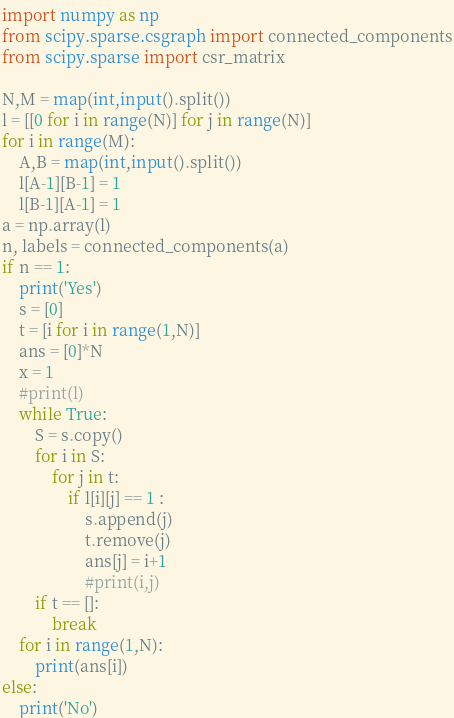<code> <loc_0><loc_0><loc_500><loc_500><_Python_>import numpy as np
from scipy.sparse.csgraph import connected_components
from scipy.sparse import csr_matrix

N,M = map(int,input().split())
l = [[0 for i in range(N)] for j in range(N)]
for i in range(M):
    A,B = map(int,input().split())
    l[A-1][B-1] = 1
    l[B-1][A-1] = 1
a = np.array(l)
n, labels = connected_components(a)
if n == 1:
    print('Yes')
    s = [0]
    t = [i for i in range(1,N)]
    ans = [0]*N
    x = 1
    #print(l)
    while True:
        S = s.copy()
        for i in S:
            for j in t:
                if l[i][j] == 1 :
                    s.append(j)
                    t.remove(j)
                    ans[j] = i+1
                    #print(i,j)
        if t == []:
            break
    for i in range(1,N):
        print(ans[i])
else:
    print('No')
</code> 